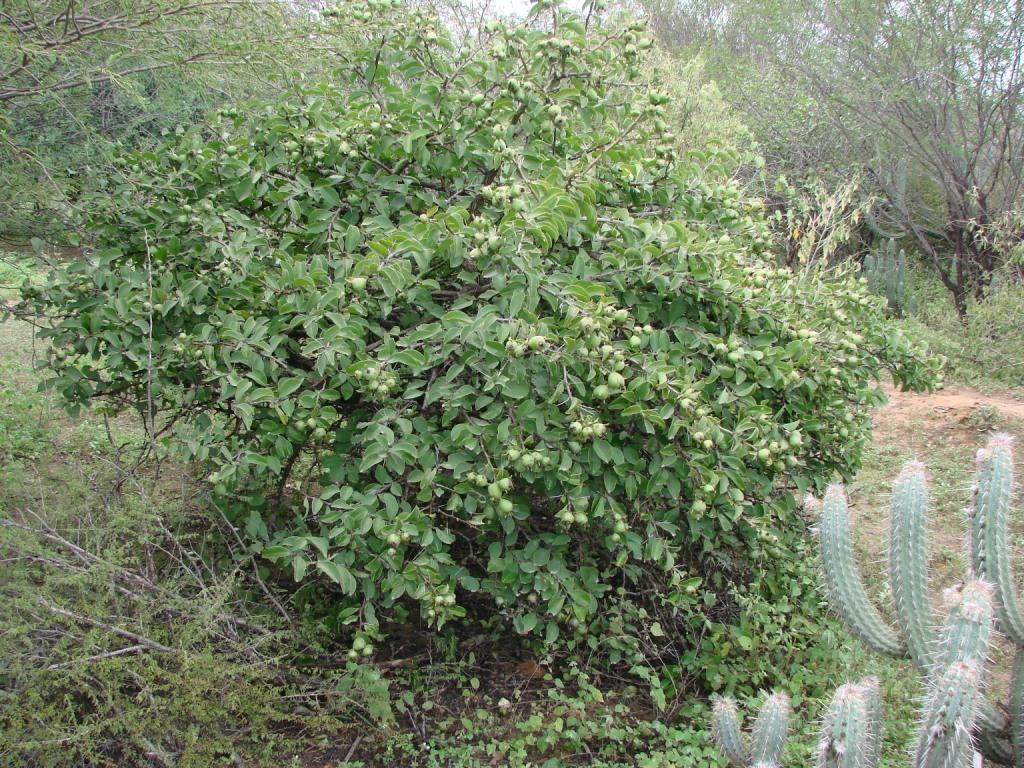Describe this image in one or two sentences. In this image we can see a tree with fruits. Also there is a cactus plant. And there are many other trees. 